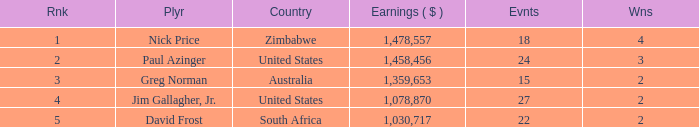How many events are in South Africa? 22.0. 